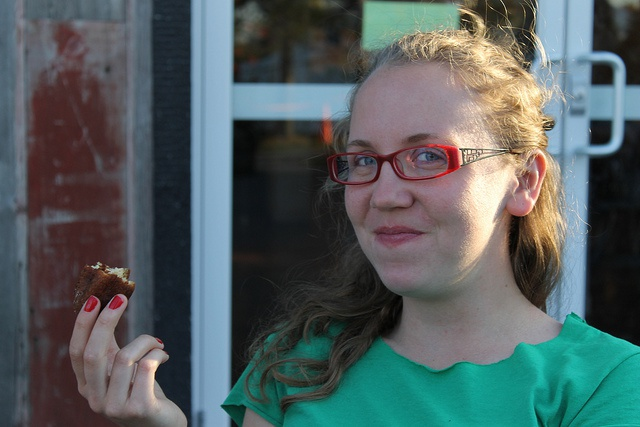Describe the objects in this image and their specific colors. I can see people in gray, black, and teal tones and donut in gray, black, maroon, and darkgray tones in this image. 